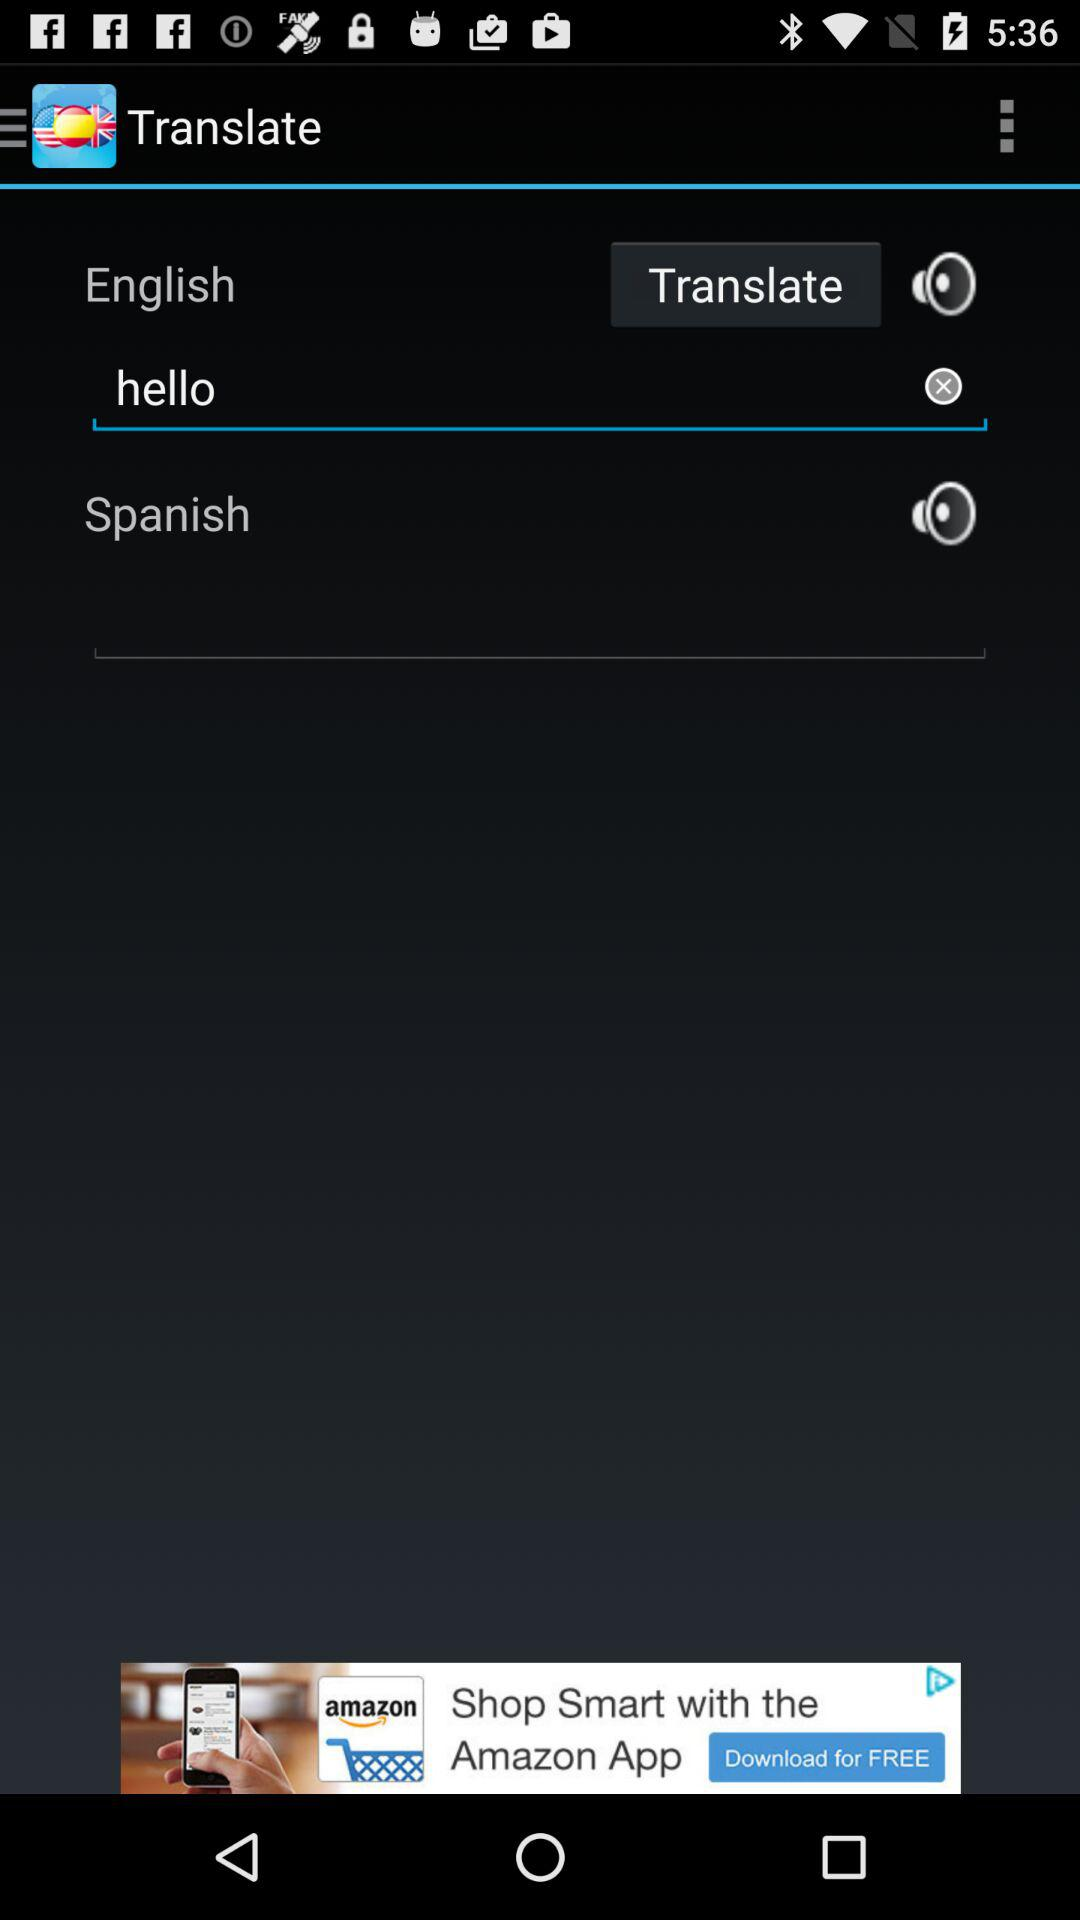In which language is the English language translated? The English language is translated into Spanish. 